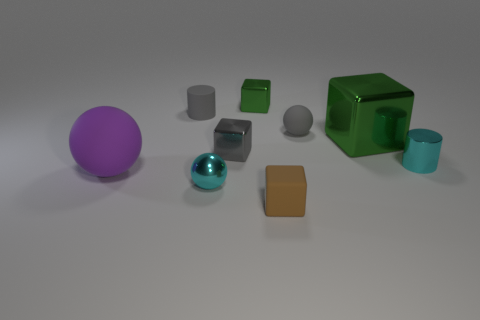Subtract all tiny cubes. How many cubes are left? 1 Subtract all gray blocks. How many blocks are left? 3 Add 1 big spheres. How many objects exist? 10 Subtract all cyan blocks. Subtract all gray balls. How many blocks are left? 4 Subtract all cylinders. How many objects are left? 7 Subtract all tiny rubber objects. Subtract all rubber balls. How many objects are left? 4 Add 3 tiny gray cylinders. How many tiny gray cylinders are left? 4 Add 3 big purple shiny cylinders. How many big purple shiny cylinders exist? 3 Subtract 0 green spheres. How many objects are left? 9 